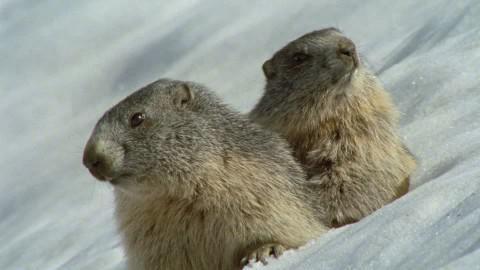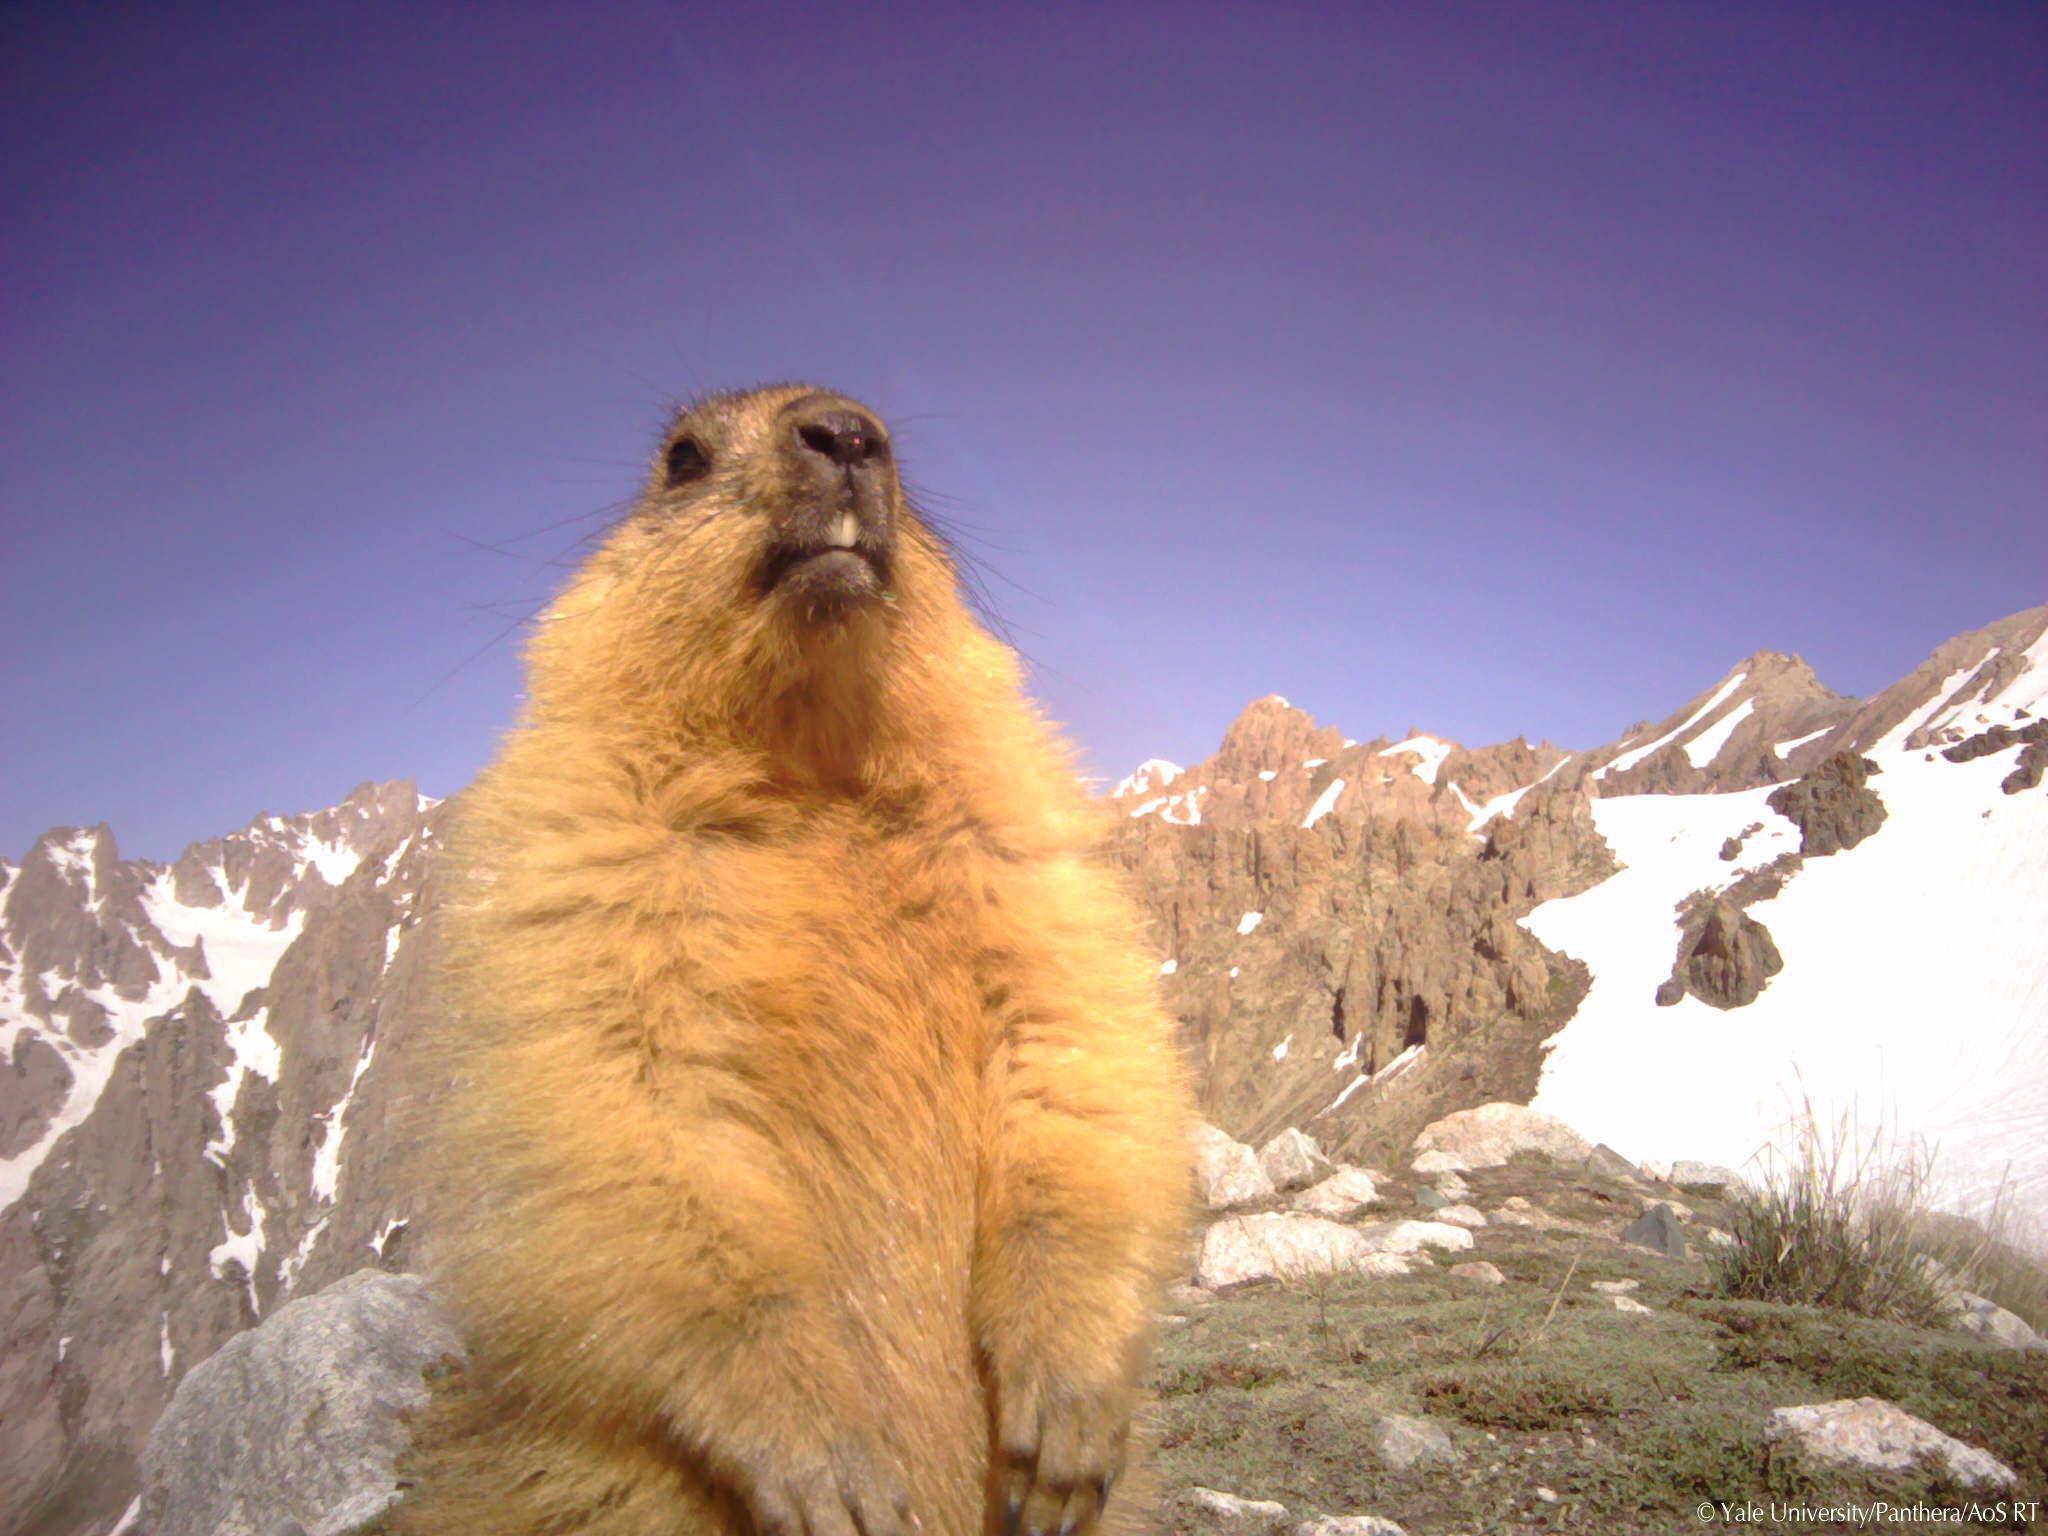The first image is the image on the left, the second image is the image on the right. Examine the images to the left and right. Is the description "There are at least 1 woodchuck poking its head out of the snow." accurate? Answer yes or no. Yes. The first image is the image on the left, the second image is the image on the right. Considering the images on both sides, is "There are 4 prairie dogs and 2 are up on their hind legs." valid? Answer yes or no. No. 